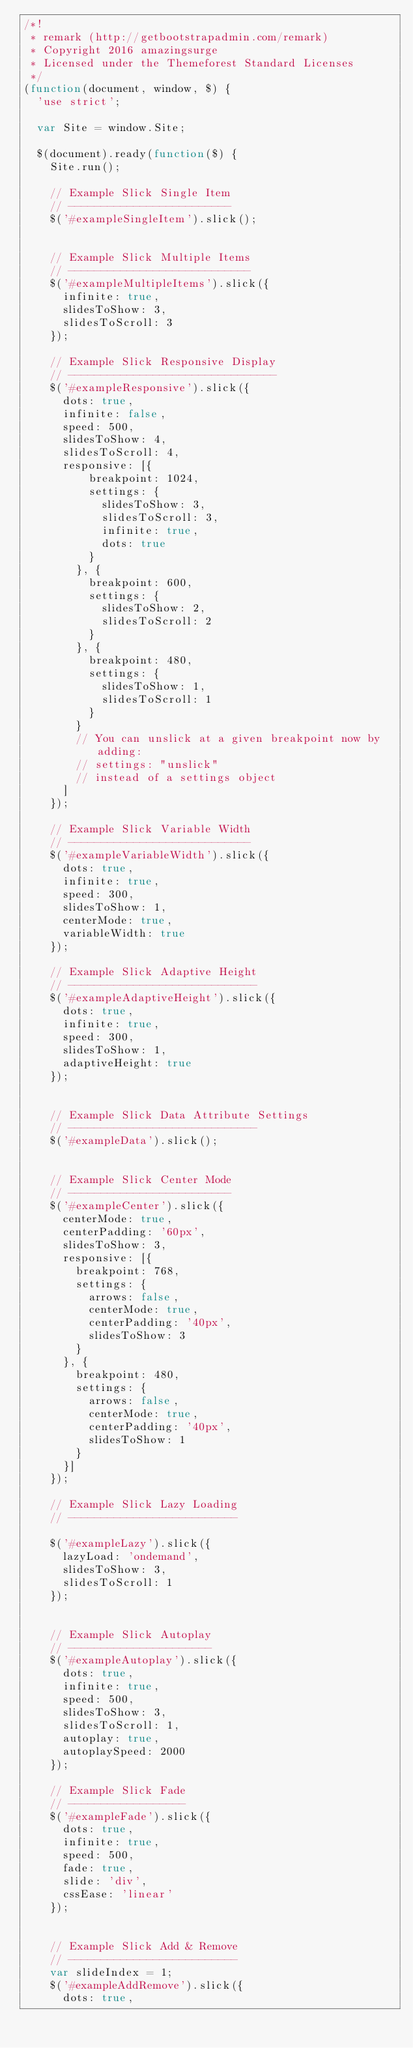<code> <loc_0><loc_0><loc_500><loc_500><_JavaScript_>/*!
 * remark (http://getbootstrapadmin.com/remark)
 * Copyright 2016 amazingsurge
 * Licensed under the Themeforest Standard Licenses
 */
(function(document, window, $) {
  'use strict';

  var Site = window.Site;

  $(document).ready(function($) {
    Site.run();

    // Example Slick Single Item
    // -------------------------
    $('#exampleSingleItem').slick();


    // Example Slick Multiple Items
    // ----------------------------
    $('#exampleMultipleItems').slick({
      infinite: true,
      slidesToShow: 3,
      slidesToScroll: 3
    });

    // Example Slick Responsive Display
    // --------------------------------
    $('#exampleResponsive').slick({
      dots: true,
      infinite: false,
      speed: 500,
      slidesToShow: 4,
      slidesToScroll: 4,
      responsive: [{
          breakpoint: 1024,
          settings: {
            slidesToShow: 3,
            slidesToScroll: 3,
            infinite: true,
            dots: true
          }
        }, {
          breakpoint: 600,
          settings: {
            slidesToShow: 2,
            slidesToScroll: 2
          }
        }, {
          breakpoint: 480,
          settings: {
            slidesToShow: 1,
            slidesToScroll: 1
          }
        }
        // You can unslick at a given breakpoint now by adding:
        // settings: "unslick"
        // instead of a settings object
      ]
    });

    // Example Slick Variable Width
    // ----------------------------
    $('#exampleVariableWidth').slick({
      dots: true,
      infinite: true,
      speed: 300,
      slidesToShow: 1,
      centerMode: true,
      variableWidth: true
    });

    // Example Slick Adaptive Height
    // -----------------------------
    $('#exampleAdaptiveHeight').slick({
      dots: true,
      infinite: true,
      speed: 300,
      slidesToShow: 1,
      adaptiveHeight: true
    });


    // Example Slick Data Attribute Settings
    // -----------------------------
    $('#exampleData').slick();


    // Example Slick Center Mode
    // -------------------------
    $('#exampleCenter').slick({
      centerMode: true,
      centerPadding: '60px',
      slidesToShow: 3,
      responsive: [{
        breakpoint: 768,
        settings: {
          arrows: false,
          centerMode: true,
          centerPadding: '40px',
          slidesToShow: 3
        }
      }, {
        breakpoint: 480,
        settings: {
          arrows: false,
          centerMode: true,
          centerPadding: '40px',
          slidesToShow: 1
        }
      }]
    });

    // Example Slick Lazy Loading
    // --------------------------

    $('#exampleLazy').slick({
      lazyLoad: 'ondemand',
      slidesToShow: 3,
      slidesToScroll: 1
    });


    // Example Slick Autoplay
    // ----------------------
    $('#exampleAutoplay').slick({
      dots: true,
      infinite: true,
      speed: 500,
      slidesToShow: 3,
      slidesToScroll: 1,
      autoplay: true,
      autoplaySpeed: 2000
    });

    // Example Slick Fade
    // ------------------
    $('#exampleFade').slick({
      dots: true,
      infinite: true,
      speed: 500,
      fade: true,
      slide: 'div',
      cssEase: 'linear'
    });


    // Example Slick Add & Remove
    // --------------------------
    var slideIndex = 1;
    $('#exampleAddRemove').slick({
      dots: true,</code> 